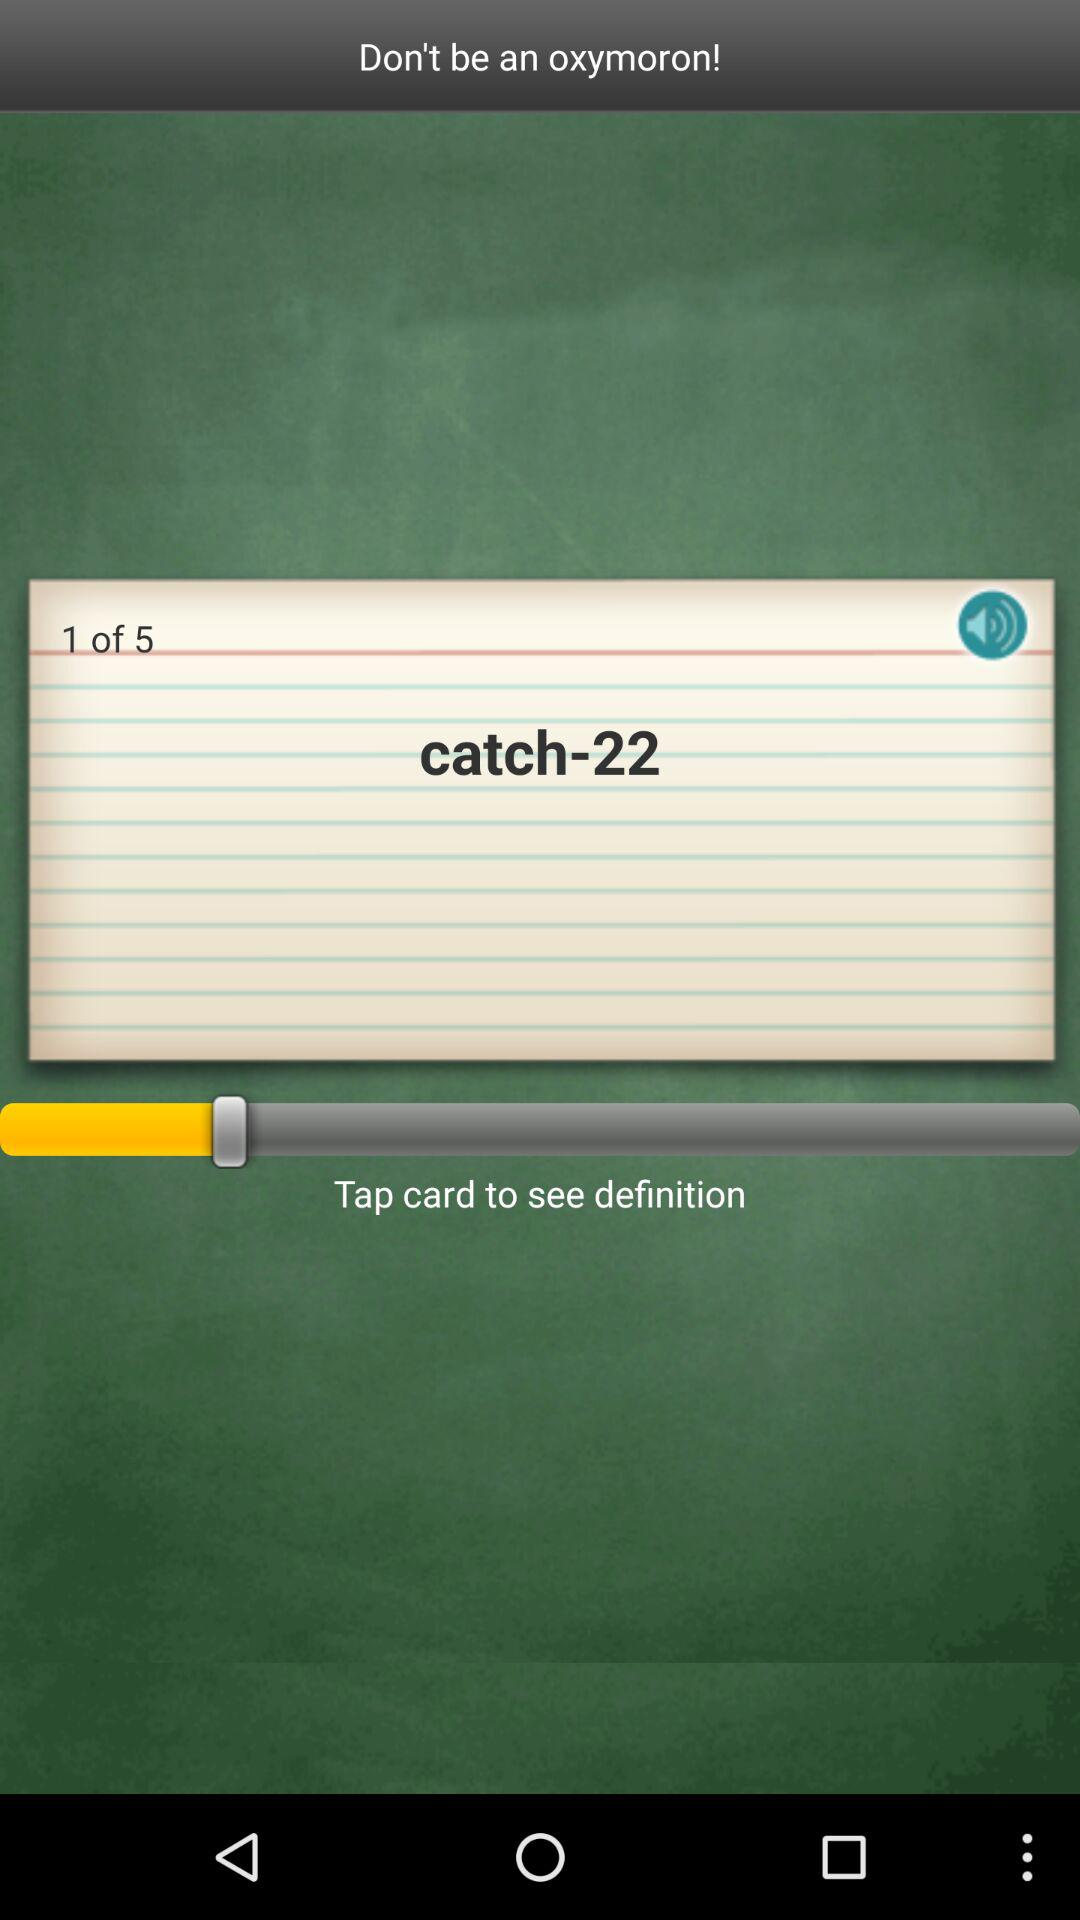Which page number is open? Page number 1 is open. 